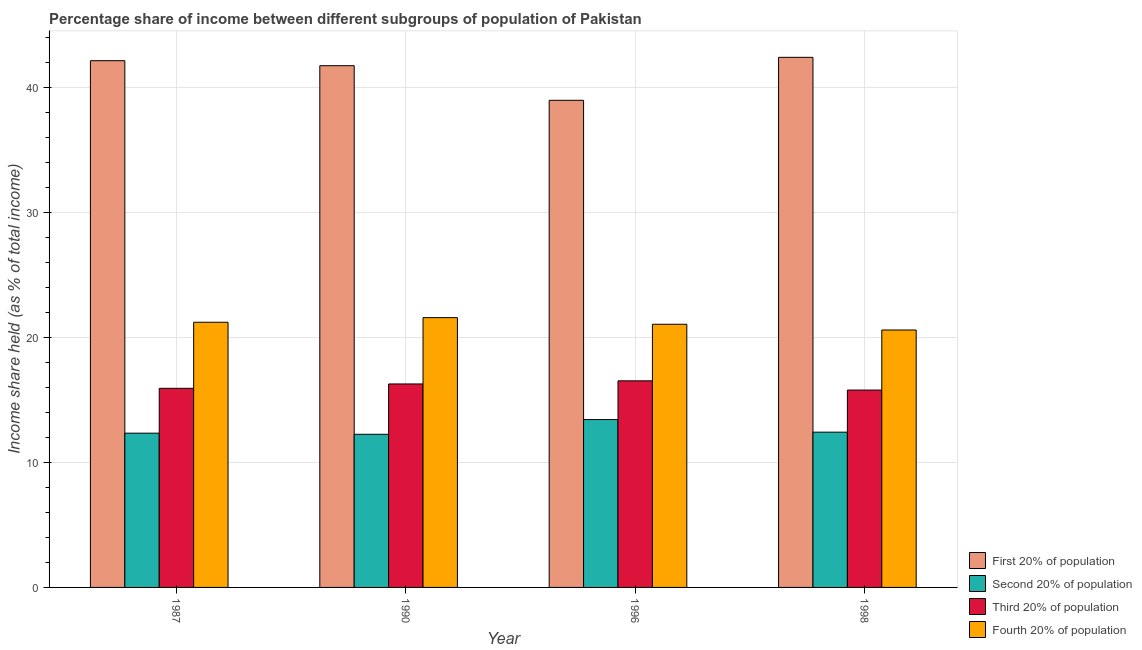Are the number of bars on each tick of the X-axis equal?
Offer a very short reply. Yes. In how many cases, is the number of bars for a given year not equal to the number of legend labels?
Your answer should be very brief. 0. What is the share of the income held by first 20% of the population in 1996?
Provide a succinct answer. 39. Across all years, what is the maximum share of the income held by fourth 20% of the population?
Give a very brief answer. 21.6. In which year was the share of the income held by first 20% of the population minimum?
Offer a terse response. 1996. What is the total share of the income held by fourth 20% of the population in the graph?
Make the answer very short. 84.51. What is the difference between the share of the income held by fourth 20% of the population in 1987 and that in 1998?
Ensure brevity in your answer.  0.62. What is the difference between the share of the income held by second 20% of the population in 1990 and the share of the income held by fourth 20% of the population in 1998?
Make the answer very short. -0.17. What is the average share of the income held by fourth 20% of the population per year?
Your answer should be compact. 21.13. What is the ratio of the share of the income held by second 20% of the population in 1990 to that in 1998?
Provide a short and direct response. 0.99. Is the share of the income held by third 20% of the population in 1990 less than that in 1998?
Give a very brief answer. No. What is the difference between the highest and the second highest share of the income held by second 20% of the population?
Provide a succinct answer. 1.01. What is the difference between the highest and the lowest share of the income held by first 20% of the population?
Your response must be concise. 3.44. Is the sum of the share of the income held by second 20% of the population in 1996 and 1998 greater than the maximum share of the income held by first 20% of the population across all years?
Make the answer very short. Yes. What does the 2nd bar from the left in 1998 represents?
Offer a terse response. Second 20% of population. What does the 3rd bar from the right in 1996 represents?
Make the answer very short. Second 20% of population. Is it the case that in every year, the sum of the share of the income held by first 20% of the population and share of the income held by second 20% of the population is greater than the share of the income held by third 20% of the population?
Ensure brevity in your answer.  Yes. How many bars are there?
Offer a very short reply. 16. Are all the bars in the graph horizontal?
Provide a succinct answer. No. Where does the legend appear in the graph?
Provide a short and direct response. Bottom right. How many legend labels are there?
Offer a terse response. 4. How are the legend labels stacked?
Your answer should be compact. Vertical. What is the title of the graph?
Offer a terse response. Percentage share of income between different subgroups of population of Pakistan. What is the label or title of the X-axis?
Your answer should be very brief. Year. What is the label or title of the Y-axis?
Offer a terse response. Income share held (as % of total income). What is the Income share held (as % of total income) in First 20% of population in 1987?
Keep it short and to the point. 42.17. What is the Income share held (as % of total income) of Second 20% of population in 1987?
Give a very brief answer. 12.35. What is the Income share held (as % of total income) in Third 20% of population in 1987?
Provide a succinct answer. 15.94. What is the Income share held (as % of total income) in Fourth 20% of population in 1987?
Your response must be concise. 21.23. What is the Income share held (as % of total income) of First 20% of population in 1990?
Give a very brief answer. 41.77. What is the Income share held (as % of total income) of Second 20% of population in 1990?
Offer a very short reply. 12.26. What is the Income share held (as % of total income) of Third 20% of population in 1990?
Your answer should be compact. 16.29. What is the Income share held (as % of total income) in Fourth 20% of population in 1990?
Make the answer very short. 21.6. What is the Income share held (as % of total income) in Second 20% of population in 1996?
Your answer should be very brief. 13.44. What is the Income share held (as % of total income) of Third 20% of population in 1996?
Give a very brief answer. 16.54. What is the Income share held (as % of total income) in Fourth 20% of population in 1996?
Your answer should be very brief. 21.07. What is the Income share held (as % of total income) in First 20% of population in 1998?
Provide a short and direct response. 42.44. What is the Income share held (as % of total income) in Second 20% of population in 1998?
Your answer should be very brief. 12.43. What is the Income share held (as % of total income) of Third 20% of population in 1998?
Make the answer very short. 15.8. What is the Income share held (as % of total income) of Fourth 20% of population in 1998?
Keep it short and to the point. 20.61. Across all years, what is the maximum Income share held (as % of total income) of First 20% of population?
Offer a very short reply. 42.44. Across all years, what is the maximum Income share held (as % of total income) of Second 20% of population?
Offer a very short reply. 13.44. Across all years, what is the maximum Income share held (as % of total income) in Third 20% of population?
Make the answer very short. 16.54. Across all years, what is the maximum Income share held (as % of total income) of Fourth 20% of population?
Make the answer very short. 21.6. Across all years, what is the minimum Income share held (as % of total income) of Second 20% of population?
Provide a succinct answer. 12.26. Across all years, what is the minimum Income share held (as % of total income) in Third 20% of population?
Provide a succinct answer. 15.8. Across all years, what is the minimum Income share held (as % of total income) of Fourth 20% of population?
Give a very brief answer. 20.61. What is the total Income share held (as % of total income) of First 20% of population in the graph?
Ensure brevity in your answer.  165.38. What is the total Income share held (as % of total income) in Second 20% of population in the graph?
Your answer should be compact. 50.48. What is the total Income share held (as % of total income) in Third 20% of population in the graph?
Offer a very short reply. 64.57. What is the total Income share held (as % of total income) of Fourth 20% of population in the graph?
Offer a very short reply. 84.51. What is the difference between the Income share held (as % of total income) in Second 20% of population in 1987 and that in 1990?
Provide a succinct answer. 0.09. What is the difference between the Income share held (as % of total income) in Third 20% of population in 1987 and that in 1990?
Provide a succinct answer. -0.35. What is the difference between the Income share held (as % of total income) of Fourth 20% of population in 1987 and that in 1990?
Offer a terse response. -0.37. What is the difference between the Income share held (as % of total income) of First 20% of population in 1987 and that in 1996?
Give a very brief answer. 3.17. What is the difference between the Income share held (as % of total income) in Second 20% of population in 1987 and that in 1996?
Keep it short and to the point. -1.09. What is the difference between the Income share held (as % of total income) of Fourth 20% of population in 1987 and that in 1996?
Provide a short and direct response. 0.16. What is the difference between the Income share held (as % of total income) in First 20% of population in 1987 and that in 1998?
Keep it short and to the point. -0.27. What is the difference between the Income share held (as % of total income) of Second 20% of population in 1987 and that in 1998?
Ensure brevity in your answer.  -0.08. What is the difference between the Income share held (as % of total income) of Third 20% of population in 1987 and that in 1998?
Ensure brevity in your answer.  0.14. What is the difference between the Income share held (as % of total income) in Fourth 20% of population in 1987 and that in 1998?
Keep it short and to the point. 0.62. What is the difference between the Income share held (as % of total income) in First 20% of population in 1990 and that in 1996?
Your response must be concise. 2.77. What is the difference between the Income share held (as % of total income) of Second 20% of population in 1990 and that in 1996?
Offer a very short reply. -1.18. What is the difference between the Income share held (as % of total income) of Fourth 20% of population in 1990 and that in 1996?
Ensure brevity in your answer.  0.53. What is the difference between the Income share held (as % of total income) of First 20% of population in 1990 and that in 1998?
Offer a very short reply. -0.67. What is the difference between the Income share held (as % of total income) in Second 20% of population in 1990 and that in 1998?
Your answer should be very brief. -0.17. What is the difference between the Income share held (as % of total income) of Third 20% of population in 1990 and that in 1998?
Your answer should be compact. 0.49. What is the difference between the Income share held (as % of total income) of First 20% of population in 1996 and that in 1998?
Your answer should be very brief. -3.44. What is the difference between the Income share held (as % of total income) in Third 20% of population in 1996 and that in 1998?
Your response must be concise. 0.74. What is the difference between the Income share held (as % of total income) of Fourth 20% of population in 1996 and that in 1998?
Keep it short and to the point. 0.46. What is the difference between the Income share held (as % of total income) of First 20% of population in 1987 and the Income share held (as % of total income) of Second 20% of population in 1990?
Ensure brevity in your answer.  29.91. What is the difference between the Income share held (as % of total income) of First 20% of population in 1987 and the Income share held (as % of total income) of Third 20% of population in 1990?
Offer a terse response. 25.88. What is the difference between the Income share held (as % of total income) of First 20% of population in 1987 and the Income share held (as % of total income) of Fourth 20% of population in 1990?
Your answer should be very brief. 20.57. What is the difference between the Income share held (as % of total income) in Second 20% of population in 1987 and the Income share held (as % of total income) in Third 20% of population in 1990?
Keep it short and to the point. -3.94. What is the difference between the Income share held (as % of total income) in Second 20% of population in 1987 and the Income share held (as % of total income) in Fourth 20% of population in 1990?
Offer a very short reply. -9.25. What is the difference between the Income share held (as % of total income) of Third 20% of population in 1987 and the Income share held (as % of total income) of Fourth 20% of population in 1990?
Keep it short and to the point. -5.66. What is the difference between the Income share held (as % of total income) of First 20% of population in 1987 and the Income share held (as % of total income) of Second 20% of population in 1996?
Your answer should be compact. 28.73. What is the difference between the Income share held (as % of total income) in First 20% of population in 1987 and the Income share held (as % of total income) in Third 20% of population in 1996?
Give a very brief answer. 25.63. What is the difference between the Income share held (as % of total income) of First 20% of population in 1987 and the Income share held (as % of total income) of Fourth 20% of population in 1996?
Give a very brief answer. 21.1. What is the difference between the Income share held (as % of total income) of Second 20% of population in 1987 and the Income share held (as % of total income) of Third 20% of population in 1996?
Provide a short and direct response. -4.19. What is the difference between the Income share held (as % of total income) in Second 20% of population in 1987 and the Income share held (as % of total income) in Fourth 20% of population in 1996?
Offer a terse response. -8.72. What is the difference between the Income share held (as % of total income) of Third 20% of population in 1987 and the Income share held (as % of total income) of Fourth 20% of population in 1996?
Keep it short and to the point. -5.13. What is the difference between the Income share held (as % of total income) of First 20% of population in 1987 and the Income share held (as % of total income) of Second 20% of population in 1998?
Provide a succinct answer. 29.74. What is the difference between the Income share held (as % of total income) in First 20% of population in 1987 and the Income share held (as % of total income) in Third 20% of population in 1998?
Provide a short and direct response. 26.37. What is the difference between the Income share held (as % of total income) in First 20% of population in 1987 and the Income share held (as % of total income) in Fourth 20% of population in 1998?
Give a very brief answer. 21.56. What is the difference between the Income share held (as % of total income) in Second 20% of population in 1987 and the Income share held (as % of total income) in Third 20% of population in 1998?
Provide a short and direct response. -3.45. What is the difference between the Income share held (as % of total income) in Second 20% of population in 1987 and the Income share held (as % of total income) in Fourth 20% of population in 1998?
Provide a succinct answer. -8.26. What is the difference between the Income share held (as % of total income) of Third 20% of population in 1987 and the Income share held (as % of total income) of Fourth 20% of population in 1998?
Your answer should be very brief. -4.67. What is the difference between the Income share held (as % of total income) of First 20% of population in 1990 and the Income share held (as % of total income) of Second 20% of population in 1996?
Give a very brief answer. 28.33. What is the difference between the Income share held (as % of total income) in First 20% of population in 1990 and the Income share held (as % of total income) in Third 20% of population in 1996?
Your answer should be compact. 25.23. What is the difference between the Income share held (as % of total income) in First 20% of population in 1990 and the Income share held (as % of total income) in Fourth 20% of population in 1996?
Offer a very short reply. 20.7. What is the difference between the Income share held (as % of total income) of Second 20% of population in 1990 and the Income share held (as % of total income) of Third 20% of population in 1996?
Keep it short and to the point. -4.28. What is the difference between the Income share held (as % of total income) in Second 20% of population in 1990 and the Income share held (as % of total income) in Fourth 20% of population in 1996?
Ensure brevity in your answer.  -8.81. What is the difference between the Income share held (as % of total income) in Third 20% of population in 1990 and the Income share held (as % of total income) in Fourth 20% of population in 1996?
Your answer should be compact. -4.78. What is the difference between the Income share held (as % of total income) of First 20% of population in 1990 and the Income share held (as % of total income) of Second 20% of population in 1998?
Provide a short and direct response. 29.34. What is the difference between the Income share held (as % of total income) of First 20% of population in 1990 and the Income share held (as % of total income) of Third 20% of population in 1998?
Provide a succinct answer. 25.97. What is the difference between the Income share held (as % of total income) of First 20% of population in 1990 and the Income share held (as % of total income) of Fourth 20% of population in 1998?
Give a very brief answer. 21.16. What is the difference between the Income share held (as % of total income) in Second 20% of population in 1990 and the Income share held (as % of total income) in Third 20% of population in 1998?
Ensure brevity in your answer.  -3.54. What is the difference between the Income share held (as % of total income) in Second 20% of population in 1990 and the Income share held (as % of total income) in Fourth 20% of population in 1998?
Make the answer very short. -8.35. What is the difference between the Income share held (as % of total income) of Third 20% of population in 1990 and the Income share held (as % of total income) of Fourth 20% of population in 1998?
Provide a succinct answer. -4.32. What is the difference between the Income share held (as % of total income) of First 20% of population in 1996 and the Income share held (as % of total income) of Second 20% of population in 1998?
Your answer should be very brief. 26.57. What is the difference between the Income share held (as % of total income) of First 20% of population in 1996 and the Income share held (as % of total income) of Third 20% of population in 1998?
Give a very brief answer. 23.2. What is the difference between the Income share held (as % of total income) of First 20% of population in 1996 and the Income share held (as % of total income) of Fourth 20% of population in 1998?
Give a very brief answer. 18.39. What is the difference between the Income share held (as % of total income) in Second 20% of population in 1996 and the Income share held (as % of total income) in Third 20% of population in 1998?
Give a very brief answer. -2.36. What is the difference between the Income share held (as % of total income) of Second 20% of population in 1996 and the Income share held (as % of total income) of Fourth 20% of population in 1998?
Provide a succinct answer. -7.17. What is the difference between the Income share held (as % of total income) of Third 20% of population in 1996 and the Income share held (as % of total income) of Fourth 20% of population in 1998?
Offer a terse response. -4.07. What is the average Income share held (as % of total income) in First 20% of population per year?
Offer a very short reply. 41.34. What is the average Income share held (as % of total income) of Second 20% of population per year?
Provide a short and direct response. 12.62. What is the average Income share held (as % of total income) of Third 20% of population per year?
Offer a very short reply. 16.14. What is the average Income share held (as % of total income) in Fourth 20% of population per year?
Your response must be concise. 21.13. In the year 1987, what is the difference between the Income share held (as % of total income) of First 20% of population and Income share held (as % of total income) of Second 20% of population?
Offer a very short reply. 29.82. In the year 1987, what is the difference between the Income share held (as % of total income) in First 20% of population and Income share held (as % of total income) in Third 20% of population?
Provide a short and direct response. 26.23. In the year 1987, what is the difference between the Income share held (as % of total income) of First 20% of population and Income share held (as % of total income) of Fourth 20% of population?
Give a very brief answer. 20.94. In the year 1987, what is the difference between the Income share held (as % of total income) in Second 20% of population and Income share held (as % of total income) in Third 20% of population?
Offer a terse response. -3.59. In the year 1987, what is the difference between the Income share held (as % of total income) of Second 20% of population and Income share held (as % of total income) of Fourth 20% of population?
Provide a short and direct response. -8.88. In the year 1987, what is the difference between the Income share held (as % of total income) in Third 20% of population and Income share held (as % of total income) in Fourth 20% of population?
Your answer should be very brief. -5.29. In the year 1990, what is the difference between the Income share held (as % of total income) in First 20% of population and Income share held (as % of total income) in Second 20% of population?
Provide a short and direct response. 29.51. In the year 1990, what is the difference between the Income share held (as % of total income) in First 20% of population and Income share held (as % of total income) in Third 20% of population?
Offer a terse response. 25.48. In the year 1990, what is the difference between the Income share held (as % of total income) in First 20% of population and Income share held (as % of total income) in Fourth 20% of population?
Make the answer very short. 20.17. In the year 1990, what is the difference between the Income share held (as % of total income) of Second 20% of population and Income share held (as % of total income) of Third 20% of population?
Ensure brevity in your answer.  -4.03. In the year 1990, what is the difference between the Income share held (as % of total income) of Second 20% of population and Income share held (as % of total income) of Fourth 20% of population?
Keep it short and to the point. -9.34. In the year 1990, what is the difference between the Income share held (as % of total income) in Third 20% of population and Income share held (as % of total income) in Fourth 20% of population?
Provide a succinct answer. -5.31. In the year 1996, what is the difference between the Income share held (as % of total income) of First 20% of population and Income share held (as % of total income) of Second 20% of population?
Your response must be concise. 25.56. In the year 1996, what is the difference between the Income share held (as % of total income) in First 20% of population and Income share held (as % of total income) in Third 20% of population?
Provide a short and direct response. 22.46. In the year 1996, what is the difference between the Income share held (as % of total income) of First 20% of population and Income share held (as % of total income) of Fourth 20% of population?
Provide a short and direct response. 17.93. In the year 1996, what is the difference between the Income share held (as % of total income) of Second 20% of population and Income share held (as % of total income) of Third 20% of population?
Offer a very short reply. -3.1. In the year 1996, what is the difference between the Income share held (as % of total income) of Second 20% of population and Income share held (as % of total income) of Fourth 20% of population?
Provide a short and direct response. -7.63. In the year 1996, what is the difference between the Income share held (as % of total income) of Third 20% of population and Income share held (as % of total income) of Fourth 20% of population?
Keep it short and to the point. -4.53. In the year 1998, what is the difference between the Income share held (as % of total income) of First 20% of population and Income share held (as % of total income) of Second 20% of population?
Keep it short and to the point. 30.01. In the year 1998, what is the difference between the Income share held (as % of total income) in First 20% of population and Income share held (as % of total income) in Third 20% of population?
Offer a very short reply. 26.64. In the year 1998, what is the difference between the Income share held (as % of total income) of First 20% of population and Income share held (as % of total income) of Fourth 20% of population?
Keep it short and to the point. 21.83. In the year 1998, what is the difference between the Income share held (as % of total income) in Second 20% of population and Income share held (as % of total income) in Third 20% of population?
Offer a terse response. -3.37. In the year 1998, what is the difference between the Income share held (as % of total income) in Second 20% of population and Income share held (as % of total income) in Fourth 20% of population?
Provide a short and direct response. -8.18. In the year 1998, what is the difference between the Income share held (as % of total income) in Third 20% of population and Income share held (as % of total income) in Fourth 20% of population?
Keep it short and to the point. -4.81. What is the ratio of the Income share held (as % of total income) of First 20% of population in 1987 to that in 1990?
Keep it short and to the point. 1.01. What is the ratio of the Income share held (as % of total income) in Second 20% of population in 1987 to that in 1990?
Your response must be concise. 1.01. What is the ratio of the Income share held (as % of total income) of Third 20% of population in 1987 to that in 1990?
Provide a succinct answer. 0.98. What is the ratio of the Income share held (as % of total income) of Fourth 20% of population in 1987 to that in 1990?
Ensure brevity in your answer.  0.98. What is the ratio of the Income share held (as % of total income) of First 20% of population in 1987 to that in 1996?
Your answer should be very brief. 1.08. What is the ratio of the Income share held (as % of total income) in Second 20% of population in 1987 to that in 1996?
Make the answer very short. 0.92. What is the ratio of the Income share held (as % of total income) in Third 20% of population in 1987 to that in 1996?
Ensure brevity in your answer.  0.96. What is the ratio of the Income share held (as % of total income) of Fourth 20% of population in 1987 to that in 1996?
Make the answer very short. 1.01. What is the ratio of the Income share held (as % of total income) of First 20% of population in 1987 to that in 1998?
Offer a terse response. 0.99. What is the ratio of the Income share held (as % of total income) in Second 20% of population in 1987 to that in 1998?
Your answer should be compact. 0.99. What is the ratio of the Income share held (as % of total income) in Third 20% of population in 1987 to that in 1998?
Ensure brevity in your answer.  1.01. What is the ratio of the Income share held (as % of total income) in Fourth 20% of population in 1987 to that in 1998?
Provide a short and direct response. 1.03. What is the ratio of the Income share held (as % of total income) of First 20% of population in 1990 to that in 1996?
Your answer should be very brief. 1.07. What is the ratio of the Income share held (as % of total income) in Second 20% of population in 1990 to that in 1996?
Your response must be concise. 0.91. What is the ratio of the Income share held (as % of total income) in Third 20% of population in 1990 to that in 1996?
Make the answer very short. 0.98. What is the ratio of the Income share held (as % of total income) of Fourth 20% of population in 1990 to that in 1996?
Your answer should be very brief. 1.03. What is the ratio of the Income share held (as % of total income) in First 20% of population in 1990 to that in 1998?
Your answer should be compact. 0.98. What is the ratio of the Income share held (as % of total income) of Second 20% of population in 1990 to that in 1998?
Offer a terse response. 0.99. What is the ratio of the Income share held (as % of total income) in Third 20% of population in 1990 to that in 1998?
Your response must be concise. 1.03. What is the ratio of the Income share held (as % of total income) of Fourth 20% of population in 1990 to that in 1998?
Your answer should be compact. 1.05. What is the ratio of the Income share held (as % of total income) in First 20% of population in 1996 to that in 1998?
Keep it short and to the point. 0.92. What is the ratio of the Income share held (as % of total income) of Second 20% of population in 1996 to that in 1998?
Make the answer very short. 1.08. What is the ratio of the Income share held (as % of total income) of Third 20% of population in 1996 to that in 1998?
Offer a terse response. 1.05. What is the ratio of the Income share held (as % of total income) of Fourth 20% of population in 1996 to that in 1998?
Offer a terse response. 1.02. What is the difference between the highest and the second highest Income share held (as % of total income) of First 20% of population?
Provide a short and direct response. 0.27. What is the difference between the highest and the second highest Income share held (as % of total income) of Fourth 20% of population?
Provide a succinct answer. 0.37. What is the difference between the highest and the lowest Income share held (as % of total income) of First 20% of population?
Make the answer very short. 3.44. What is the difference between the highest and the lowest Income share held (as % of total income) in Second 20% of population?
Keep it short and to the point. 1.18. What is the difference between the highest and the lowest Income share held (as % of total income) in Third 20% of population?
Give a very brief answer. 0.74. What is the difference between the highest and the lowest Income share held (as % of total income) in Fourth 20% of population?
Provide a short and direct response. 0.99. 